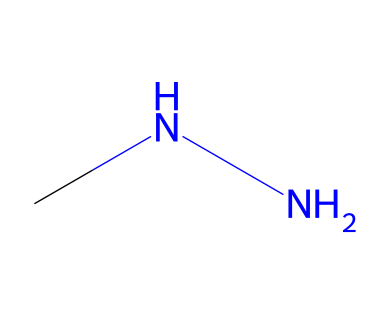how many nitrogen atoms are in this compound? The chemical structure represented in the SMILES shows two nitrogen atoms connected by a single bond and also attached to the carbon atom, indicating that there are two nitrogen atoms total.
Answer: two what is the molecular formula of monomethylhydrazine? By analyzing the SMILES, we see there is one carbon (C), two nitrogen (N), and six hydrogen (H) atoms connected; thus, the molecular formula is C1H6N2.
Answer: C1H6N2 how many hydrogen atoms are bonded to the nitrogen atoms in this structure? In the SMILES representation, we can see that each nitrogen is connected to additional hydrogen atoms. Specifically, one nitrogen atom bonds with two hydrogen atoms while the other nitrogen is attached to one hydrogen atom, giving a total of three hydrogen atoms bonded to nitrogen.
Answer: three what type of functional group is present in monomethylhydrazine? The presence of the NH2 groups (as indicated by the two nitrogen atoms connected to hydrogens in the SMILES) identifies it as an amine group. Hence, it consists of hydrazine functional group characteristics as well.
Answer: hydrazine is this compound polar or nonpolar? The structure contains functional groups with significant electronegativity differences, specifically nitrogen and hydrogen, which leads to the compound having a dipole moment. Thus, the distribution of charge signifies that monomethylhydrazine is polar.
Answer: polar what unique attribute does hydrazine's structure provide for its use in chemical applications? The combination of nitrogen and hydrogen within the structure leads to the property of high reactivity, particularly due to the nitrogen-nitrogen bond and the ability to release gases, making it useful in applications like rocket propellants and reactive agents in organic synthesis.
Answer: high reactivity 